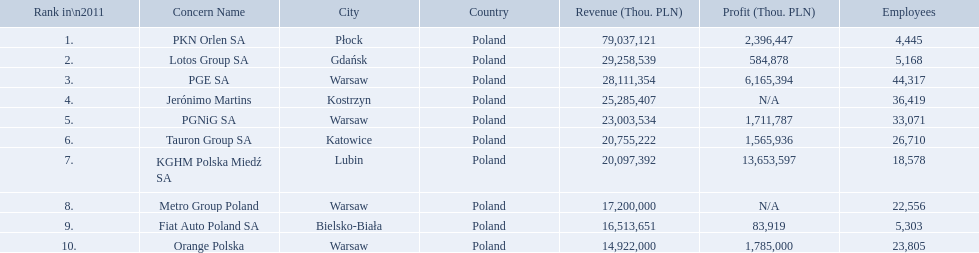What are the names of the major companies of poland? PKN Orlen SA, Lotos Group SA, PGE SA, Jerónimo Martins, PGNiG SA, Tauron Group SA, KGHM Polska Miedź SA, Metro Group Poland, Fiat Auto Poland SA, Orange Polska. What are the revenues of those companies in thou. pln? PKN Orlen SA, 79 037 121, Lotos Group SA, 29 258 539, PGE SA, 28 111 354, Jerónimo Martins, 25 285 407, PGNiG SA, 23 003 534, Tauron Group SA, 20 755 222, KGHM Polska Miedź SA, 20 097 392, Metro Group Poland, 17 200 000, Fiat Auto Poland SA, 16 513 651, Orange Polska, 14 922 000. Which of these revenues is greater than 75 000 000 thou. pln? 79 037 121. Which company has a revenue equal to 79 037 121 thou pln? PKN Orlen SA. 